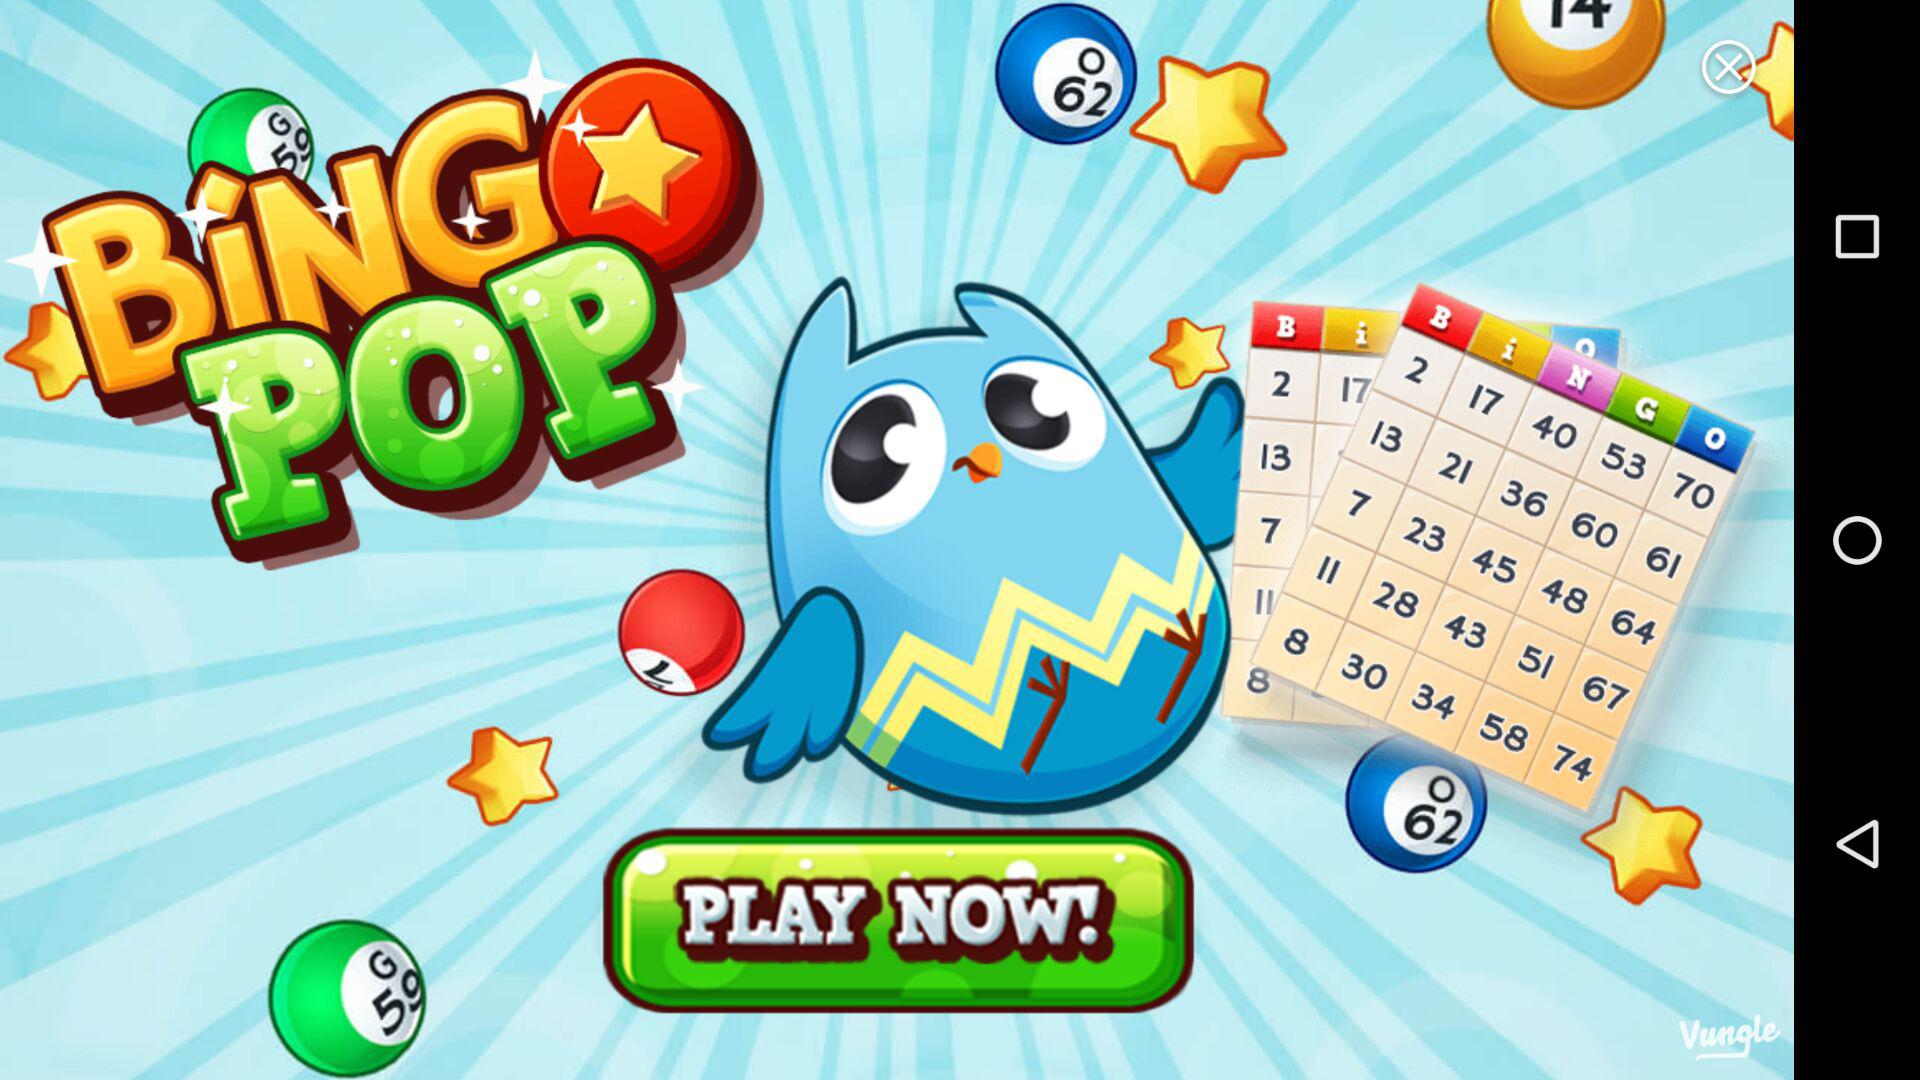How many days have rewards?
Answer the question using a single word or phrase. 5 